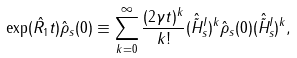Convert formula to latex. <formula><loc_0><loc_0><loc_500><loc_500>\exp ( \hat { R _ { 1 } } t ) \hat { \rho } _ { s } ( 0 ) \equiv \sum _ { k = 0 } ^ { \infty } \frac { ( 2 \gamma t ) ^ { k } } { k ! } ( \hat { \tilde { H } } ^ { I } _ { s } ) ^ { k } \hat { \rho } _ { s } ( 0 ) ( \hat { \tilde { H } } ^ { I } _ { s } ) ^ { k } ,</formula> 